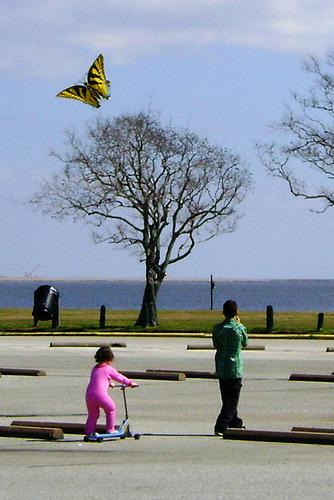The kite here is designed to resemble what? Please explain your reasoning. butterfly. Monarchs have yellow base and black accents. 